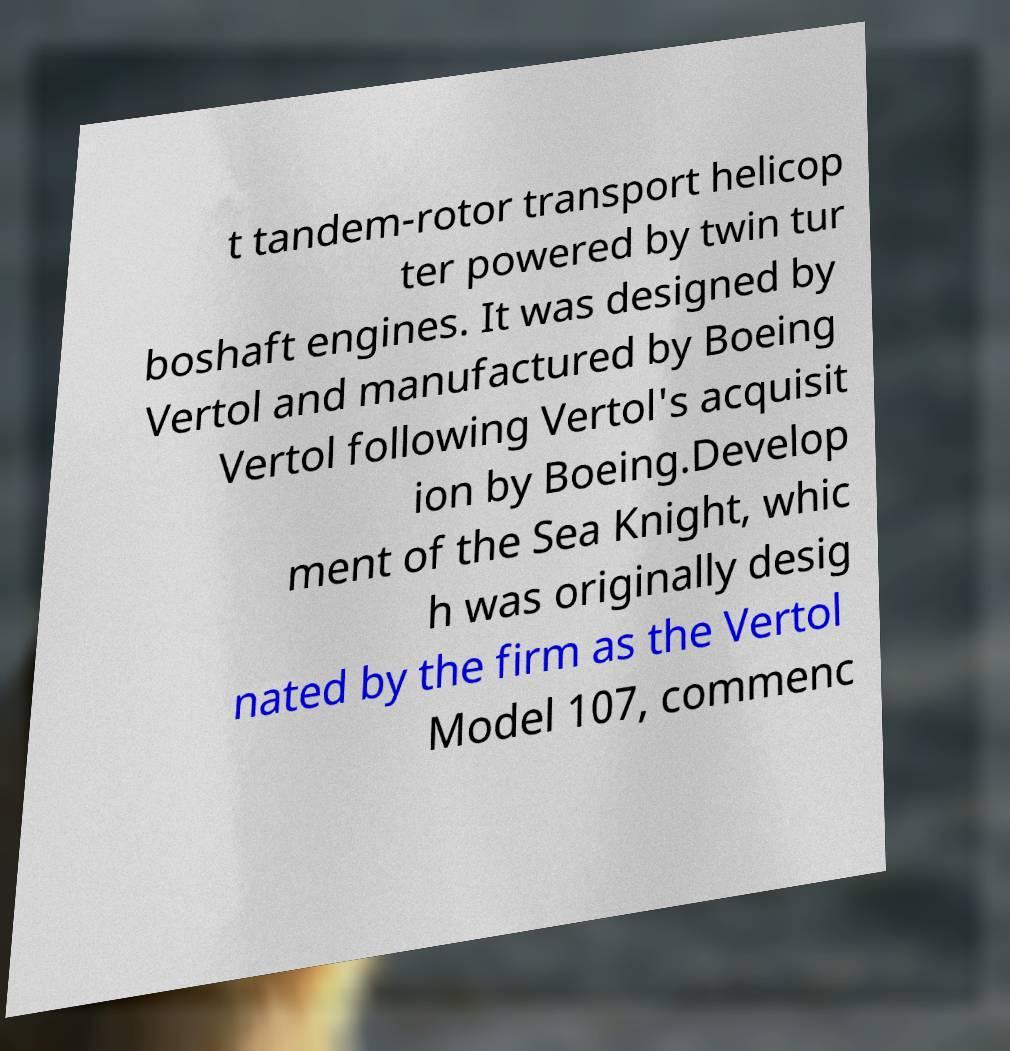I need the written content from this picture converted into text. Can you do that? t tandem-rotor transport helicop ter powered by twin tur boshaft engines. It was designed by Vertol and manufactured by Boeing Vertol following Vertol's acquisit ion by Boeing.Develop ment of the Sea Knight, whic h was originally desig nated by the firm as the Vertol Model 107, commenc 